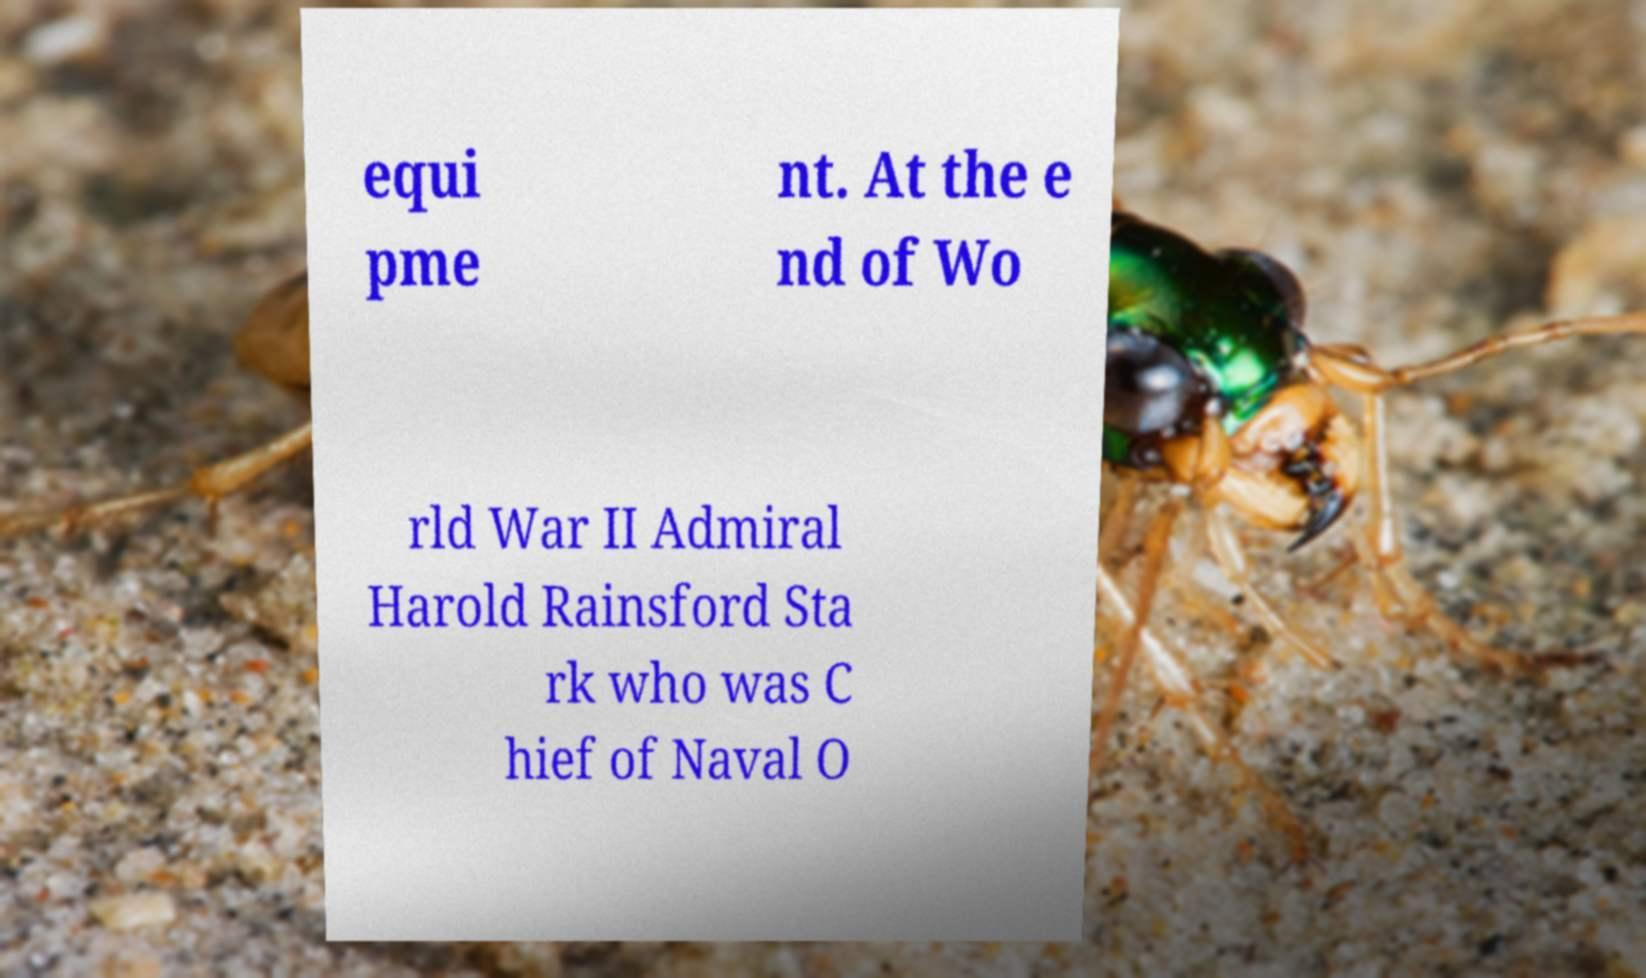Please identify and transcribe the text found in this image. equi pme nt. At the e nd of Wo rld War II Admiral Harold Rainsford Sta rk who was C hief of Naval O 